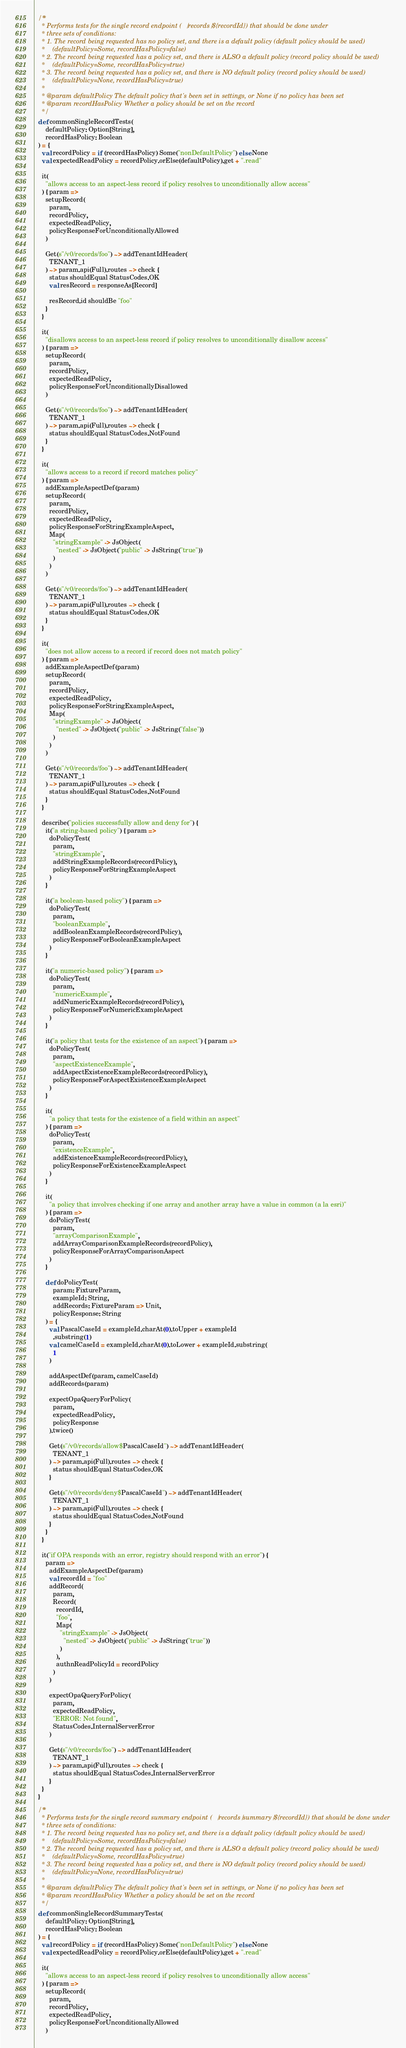Convert code to text. <code><loc_0><loc_0><loc_500><loc_500><_Scala_>
  /**
    * Performs tests for the single record endpoint (/records/${recordId}) that should be done under
    * three sets of conditions:
    * 1. The record being requested has no policy set, and there is a default policy (default policy should be used)
    *    (defaultPolicy=Some, recordHasPolicy=false)
    * 2. The record being requested has a policy set, and there is ALSO a default policy (record policy should be used)
    *    (defaultPolicy=Some, recordHasPolicy=true)
    * 3. The record being requested has a policy set, and there is NO default policy (record policy should be used)
    *    (defaultPolicy=None, recordHasPolicy=true)
    *
    * @param defaultPolicy The default policy that's been set in settings, or None if no policy has been set
    * @param recordHasPolicy Whether a policy should be set on the record
    */
  def commonSingleRecordTests(
      defaultPolicy: Option[String],
      recordHasPolicy: Boolean
  ) = {
    val recordPolicy = if (recordHasPolicy) Some("nonDefaultPolicy") else None
    val expectedReadPolicy = recordPolicy.orElse(defaultPolicy).get + ".read"

    it(
      "allows access to an aspect-less record if policy resolves to unconditionally allow access"
    ) { param =>
      setupRecord(
        param,
        recordPolicy,
        expectedReadPolicy,
        policyResponseForUnconditionallyAllowed
      )

      Get(s"/v0/records/foo") ~> addTenantIdHeader(
        TENANT_1
      ) ~> param.api(Full).routes ~> check {
        status shouldEqual StatusCodes.OK
        val resRecord = responseAs[Record]

        resRecord.id shouldBe "foo"
      }
    }

    it(
      "disallows access to an aspect-less record if policy resolves to unconditionally disallow access"
    ) { param =>
      setupRecord(
        param,
        recordPolicy,
        expectedReadPolicy,
        policyResponseForUnconditionallyDisallowed
      )

      Get(s"/v0/records/foo") ~> addTenantIdHeader(
        TENANT_1
      ) ~> param.api(Full).routes ~> check {
        status shouldEqual StatusCodes.NotFound
      }
    }

    it(
      "allows access to a record if record matches policy"
    ) { param =>
      addExampleAspectDef(param)
      setupRecord(
        param,
        recordPolicy,
        expectedReadPolicy,
        policyResponseForStringExampleAspect,
        Map(
          "stringExample" -> JsObject(
            "nested" -> JsObject("public" -> JsString("true"))
          )
        )
      )

      Get(s"/v0/records/foo") ~> addTenantIdHeader(
        TENANT_1
      ) ~> param.api(Full).routes ~> check {
        status shouldEqual StatusCodes.OK
      }
    }

    it(
      "does not allow access to a record if record does not match policy"
    ) { param =>
      addExampleAspectDef(param)
      setupRecord(
        param,
        recordPolicy,
        expectedReadPolicy,
        policyResponseForStringExampleAspect,
        Map(
          "stringExample" -> JsObject(
            "nested" -> JsObject("public" -> JsString("false"))
          )
        )
      )

      Get(s"/v0/records/foo") ~> addTenantIdHeader(
        TENANT_1
      ) ~> param.api(Full).routes ~> check {
        status shouldEqual StatusCodes.NotFound
      }
    }

    describe("policies successfully allow and deny for") {
      it("a string-based policy") { param =>
        doPolicyTest(
          param,
          "stringExample",
          addStringExampleRecords(recordPolicy),
          policyResponseForStringExampleAspect
        )
      }

      it("a boolean-based policy") { param =>
        doPolicyTest(
          param,
          "booleanExample",
          addBooleanExampleRecords(recordPolicy),
          policyResponseForBooleanExampleAspect
        )
      }

      it("a numeric-based policy") { param =>
        doPolicyTest(
          param,
          "numericExample",
          addNumericExampleRecords(recordPolicy),
          policyResponseForNumericExampleAspect
        )
      }

      it("a policy that tests for the existence of an aspect") { param =>
        doPolicyTest(
          param,
          "aspectExistenceExample",
          addAspectExistenceExampleRecords(recordPolicy),
          policyResponseForAspectExistenceExampleAspect
        )
      }

      it(
        "a policy that tests for the existence of a field within an aspect"
      ) { param =>
        doPolicyTest(
          param,
          "existenceExample",
          addExistenceExampleRecords(recordPolicy),
          policyResponseForExistenceExampleAspect
        )
      }

      it(
        "a policy that involves checking if one array and another array have a value in common (a la esri)"
      ) { param =>
        doPolicyTest(
          param,
          "arrayComparisonExample",
          addArrayComparisonExampleRecords(recordPolicy),
          policyResponseForArrayComparisonAspect
        )
      }

      def doPolicyTest(
          param: FixtureParam,
          exampleId: String,
          addRecords: FixtureParam => Unit,
          policyResponse: String
      ) = {
        val PascalCaseId = exampleId.charAt(0).toUpper + exampleId
          .substring(1)
        val camelCaseId = exampleId.charAt(0).toLower + exampleId.substring(
          1
        )

        addAspectDef(param, camelCaseId)
        addRecords(param)

        expectOpaQueryForPolicy(
          param,
          expectedReadPolicy,
          policyResponse
        ).twice()

        Get(s"/v0/records/allow$PascalCaseId") ~> addTenantIdHeader(
          TENANT_1
        ) ~> param.api(Full).routes ~> check {
          status shouldEqual StatusCodes.OK
        }

        Get(s"/v0/records/deny$PascalCaseId") ~> addTenantIdHeader(
          TENANT_1
        ) ~> param.api(Full).routes ~> check {
          status shouldEqual StatusCodes.NotFound
        }
      }
    }

    it("if OPA responds with an error, registry should respond with an error") {
      param =>
        addExampleAspectDef(param)
        val recordId = "foo"
        addRecord(
          param,
          Record(
            recordId,
            "foo",
            Map(
              "stringExample" -> JsObject(
                "nested" -> JsObject("public" -> JsString("true"))
              )
            ),
            authnReadPolicyId = recordPolicy
          )
        )

        expectOpaQueryForPolicy(
          param,
          expectedReadPolicy,
          "ERROR: Not found",
          StatusCodes.InternalServerError
        )

        Get(s"/v0/records/foo") ~> addTenantIdHeader(
          TENANT_1
        ) ~> param.api(Full).routes ~> check {
          status shouldEqual StatusCodes.InternalServerError
        }
    }
  }

  /**
    * Performs tests for the single record summary endpoint (/records/summary/${recordId}) that should be done under
    * three sets of conditions:
    * 1. The record being requested has no policy set, and there is a default policy (default policy should be used)
    *    (defaultPolicy=Some, recordHasPolicy=false)
    * 2. The record being requested has a policy set, and there is ALSO a default policy (record policy should be used)
    *    (defaultPolicy=Some, recordHasPolicy=true)
    * 3. The record being requested has a policy set, and there is NO default policy (record policy should be used)
    *    (defaultPolicy=None, recordHasPolicy=true)
    *
    * @param defaultPolicy The default policy that's been set in settings, or None if no policy has been set
    * @param recordHasPolicy Whether a policy should be set on the record
    */
  def commonSingleRecordSummaryTests(
      defaultPolicy: Option[String],
      recordHasPolicy: Boolean
  ) = {
    val recordPolicy = if (recordHasPolicy) Some("nonDefaultPolicy") else None
    val expectedReadPolicy = recordPolicy.orElse(defaultPolicy).get + ".read"

    it(
      "allows access to an aspect-less record if policy resolves to unconditionally allow access"
    ) { param =>
      setupRecord(
        param,
        recordPolicy,
        expectedReadPolicy,
        policyResponseForUnconditionallyAllowed
      )
</code> 